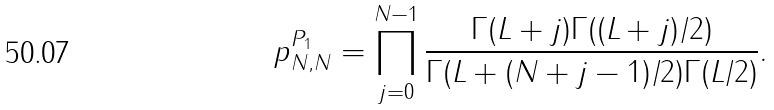<formula> <loc_0><loc_0><loc_500><loc_500>p _ { N , N } ^ { P _ { 1 } } = \prod _ { j = 0 } ^ { N - 1 } \frac { \Gamma ( L + j ) \Gamma ( ( L + j ) / 2 ) } { \Gamma ( L + ( N + j - 1 ) / 2 ) \Gamma ( L / 2 ) } .</formula> 